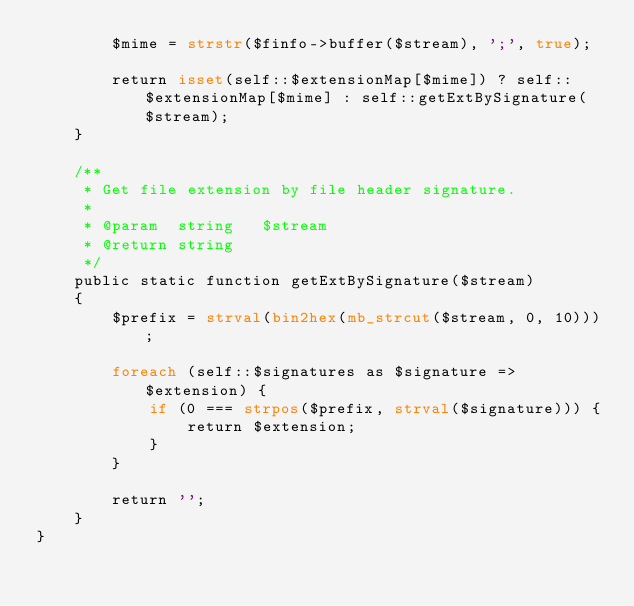<code> <loc_0><loc_0><loc_500><loc_500><_PHP_>        $mime = strstr($finfo->buffer($stream), ';', true);

        return isset(self::$extensionMap[$mime]) ? self::$extensionMap[$mime] : self::getExtBySignature($stream);
    }

    /**
     * Get file extension by file header signature.
     *
     * @param  string   $stream
     * @return string
     */
    public static function getExtBySignature($stream)
    {
        $prefix = strval(bin2hex(mb_strcut($stream, 0, 10)));

        foreach (self::$signatures as $signature => $extension) {
            if (0 === strpos($prefix, strval($signature))) {
                return $extension;
            }
        }

        return '';
    }
}
</code> 